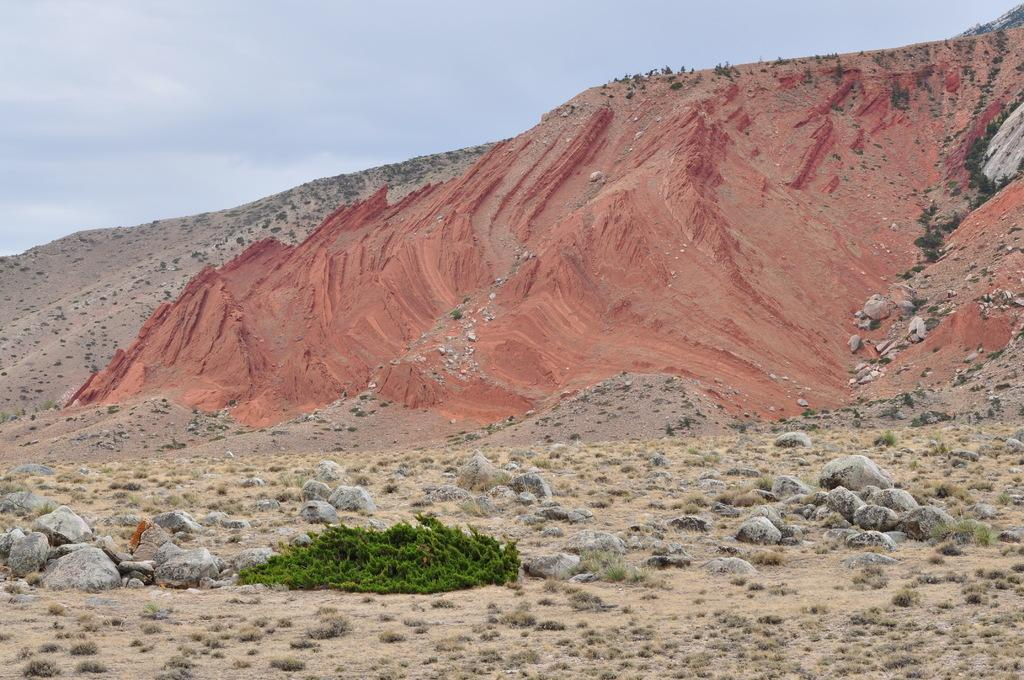What is the main geological feature in the image? There is an outcrop in the image. What type of vegetation can be seen at the bottom side of the image? There is greenery at the bottom side of the image. What historical event is being commemorated at the outcrop in the image? There is no indication of any historical event being commemorated at the outcrop in the image. 